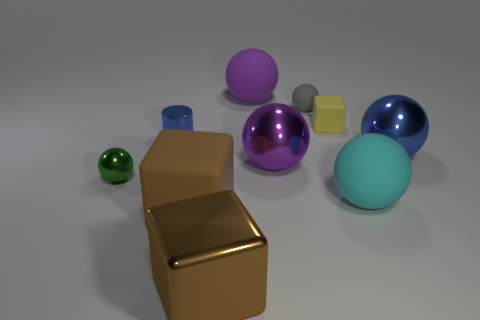What is the color of the tiny sphere on the left side of the metallic thing that is in front of the shiny ball that is left of the brown metal object?
Make the answer very short. Green. How big is the block that is behind the blue object left of the small gray ball?
Your answer should be very brief. Small. What is the material of the thing that is in front of the cyan rubber thing and to the left of the large brown metallic cube?
Keep it short and to the point. Rubber. There is a yellow thing; is its size the same as the matte cube that is on the left side of the big brown metallic object?
Offer a very short reply. No. Are any yellow spheres visible?
Your answer should be very brief. No. What is the material of the large blue object that is the same shape as the tiny green metal object?
Give a very brief answer. Metal. What is the size of the cube that is behind the blue metallic thing that is on the right side of the brown block right of the large rubber block?
Ensure brevity in your answer.  Small. Are there any cyan matte things in front of the purple metal ball?
Give a very brief answer. Yes. The purple ball that is the same material as the tiny blue thing is what size?
Ensure brevity in your answer.  Large. What number of large blue things have the same shape as the small yellow object?
Ensure brevity in your answer.  0. 